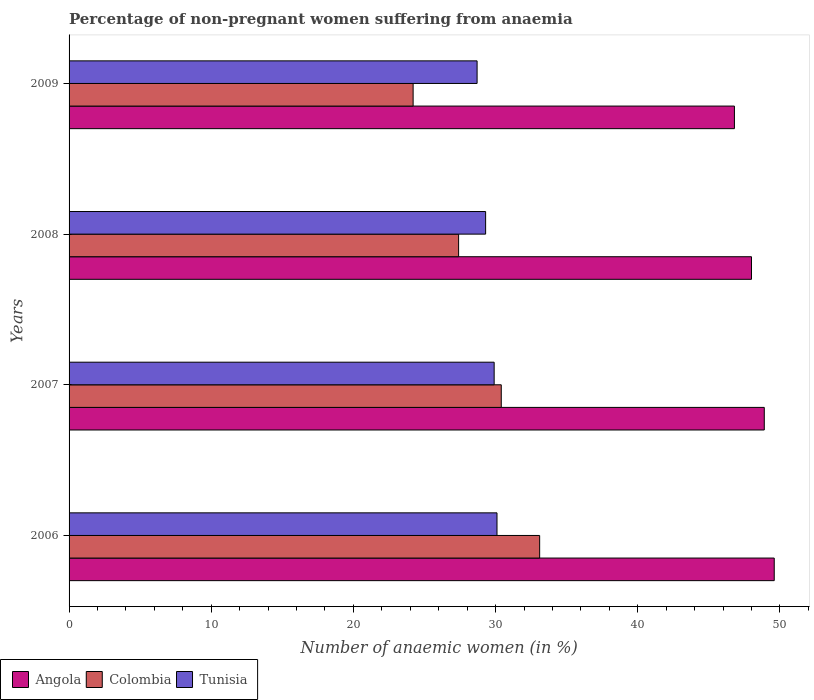How many bars are there on the 4th tick from the top?
Provide a succinct answer. 3. How many bars are there on the 2nd tick from the bottom?
Keep it short and to the point. 3. What is the label of the 3rd group of bars from the top?
Make the answer very short. 2007. What is the percentage of non-pregnant women suffering from anaemia in Angola in 2006?
Keep it short and to the point. 49.6. Across all years, what is the maximum percentage of non-pregnant women suffering from anaemia in Colombia?
Your answer should be very brief. 33.1. Across all years, what is the minimum percentage of non-pregnant women suffering from anaemia in Tunisia?
Make the answer very short. 28.7. In which year was the percentage of non-pregnant women suffering from anaemia in Colombia minimum?
Give a very brief answer. 2009. What is the total percentage of non-pregnant women suffering from anaemia in Angola in the graph?
Your response must be concise. 193.3. What is the difference between the percentage of non-pregnant women suffering from anaemia in Colombia in 2008 and that in 2009?
Your answer should be compact. 3.2. What is the difference between the percentage of non-pregnant women suffering from anaemia in Colombia in 2006 and the percentage of non-pregnant women suffering from anaemia in Tunisia in 2008?
Ensure brevity in your answer.  3.8. What is the average percentage of non-pregnant women suffering from anaemia in Colombia per year?
Make the answer very short. 28.78. In the year 2007, what is the difference between the percentage of non-pregnant women suffering from anaemia in Colombia and percentage of non-pregnant women suffering from anaemia in Tunisia?
Your answer should be very brief. 0.5. What is the ratio of the percentage of non-pregnant women suffering from anaemia in Tunisia in 2006 to that in 2008?
Keep it short and to the point. 1.03. Is the difference between the percentage of non-pregnant women suffering from anaemia in Colombia in 2006 and 2007 greater than the difference between the percentage of non-pregnant women suffering from anaemia in Tunisia in 2006 and 2007?
Offer a very short reply. Yes. What is the difference between the highest and the second highest percentage of non-pregnant women suffering from anaemia in Colombia?
Your response must be concise. 2.7. What is the difference between the highest and the lowest percentage of non-pregnant women suffering from anaemia in Colombia?
Offer a terse response. 8.9. In how many years, is the percentage of non-pregnant women suffering from anaemia in Colombia greater than the average percentage of non-pregnant women suffering from anaemia in Colombia taken over all years?
Your response must be concise. 2. What does the 1st bar from the top in 2007 represents?
Your answer should be very brief. Tunisia. What does the 3rd bar from the bottom in 2007 represents?
Keep it short and to the point. Tunisia. Is it the case that in every year, the sum of the percentage of non-pregnant women suffering from anaemia in Colombia and percentage of non-pregnant women suffering from anaemia in Tunisia is greater than the percentage of non-pregnant women suffering from anaemia in Angola?
Your response must be concise. Yes. Does the graph contain grids?
Make the answer very short. No. How many legend labels are there?
Offer a terse response. 3. What is the title of the graph?
Provide a succinct answer. Percentage of non-pregnant women suffering from anaemia. Does "Europe(all income levels)" appear as one of the legend labels in the graph?
Provide a short and direct response. No. What is the label or title of the X-axis?
Your answer should be compact. Number of anaemic women (in %). What is the label or title of the Y-axis?
Your response must be concise. Years. What is the Number of anaemic women (in %) of Angola in 2006?
Your answer should be very brief. 49.6. What is the Number of anaemic women (in %) of Colombia in 2006?
Provide a short and direct response. 33.1. What is the Number of anaemic women (in %) of Tunisia in 2006?
Offer a terse response. 30.1. What is the Number of anaemic women (in %) in Angola in 2007?
Your answer should be compact. 48.9. What is the Number of anaemic women (in %) of Colombia in 2007?
Your answer should be compact. 30.4. What is the Number of anaemic women (in %) in Tunisia in 2007?
Keep it short and to the point. 29.9. What is the Number of anaemic women (in %) of Colombia in 2008?
Give a very brief answer. 27.4. What is the Number of anaemic women (in %) in Tunisia in 2008?
Keep it short and to the point. 29.3. What is the Number of anaemic women (in %) of Angola in 2009?
Offer a very short reply. 46.8. What is the Number of anaemic women (in %) in Colombia in 2009?
Your response must be concise. 24.2. What is the Number of anaemic women (in %) of Tunisia in 2009?
Make the answer very short. 28.7. Across all years, what is the maximum Number of anaemic women (in %) in Angola?
Make the answer very short. 49.6. Across all years, what is the maximum Number of anaemic women (in %) of Colombia?
Your answer should be very brief. 33.1. Across all years, what is the maximum Number of anaemic women (in %) of Tunisia?
Your answer should be compact. 30.1. Across all years, what is the minimum Number of anaemic women (in %) in Angola?
Offer a very short reply. 46.8. Across all years, what is the minimum Number of anaemic women (in %) of Colombia?
Offer a very short reply. 24.2. Across all years, what is the minimum Number of anaemic women (in %) of Tunisia?
Provide a short and direct response. 28.7. What is the total Number of anaemic women (in %) in Angola in the graph?
Give a very brief answer. 193.3. What is the total Number of anaemic women (in %) of Colombia in the graph?
Your answer should be compact. 115.1. What is the total Number of anaemic women (in %) of Tunisia in the graph?
Provide a short and direct response. 118. What is the difference between the Number of anaemic women (in %) of Tunisia in 2006 and that in 2007?
Your answer should be compact. 0.2. What is the difference between the Number of anaemic women (in %) of Tunisia in 2006 and that in 2008?
Keep it short and to the point. 0.8. What is the difference between the Number of anaemic women (in %) in Colombia in 2006 and that in 2009?
Keep it short and to the point. 8.9. What is the difference between the Number of anaemic women (in %) in Angola in 2007 and that in 2008?
Your answer should be compact. 0.9. What is the difference between the Number of anaemic women (in %) in Angola in 2007 and that in 2009?
Ensure brevity in your answer.  2.1. What is the difference between the Number of anaemic women (in %) of Tunisia in 2007 and that in 2009?
Your answer should be very brief. 1.2. What is the difference between the Number of anaemic women (in %) of Angola in 2008 and that in 2009?
Give a very brief answer. 1.2. What is the difference between the Number of anaemic women (in %) in Colombia in 2008 and that in 2009?
Your response must be concise. 3.2. What is the difference between the Number of anaemic women (in %) in Tunisia in 2008 and that in 2009?
Make the answer very short. 0.6. What is the difference between the Number of anaemic women (in %) in Angola in 2006 and the Number of anaemic women (in %) in Colombia in 2007?
Make the answer very short. 19.2. What is the difference between the Number of anaemic women (in %) of Angola in 2006 and the Number of anaemic women (in %) of Tunisia in 2007?
Keep it short and to the point. 19.7. What is the difference between the Number of anaemic women (in %) in Colombia in 2006 and the Number of anaemic women (in %) in Tunisia in 2007?
Your answer should be compact. 3.2. What is the difference between the Number of anaemic women (in %) of Angola in 2006 and the Number of anaemic women (in %) of Colombia in 2008?
Offer a very short reply. 22.2. What is the difference between the Number of anaemic women (in %) in Angola in 2006 and the Number of anaemic women (in %) in Tunisia in 2008?
Provide a short and direct response. 20.3. What is the difference between the Number of anaemic women (in %) of Angola in 2006 and the Number of anaemic women (in %) of Colombia in 2009?
Provide a short and direct response. 25.4. What is the difference between the Number of anaemic women (in %) in Angola in 2006 and the Number of anaemic women (in %) in Tunisia in 2009?
Make the answer very short. 20.9. What is the difference between the Number of anaemic women (in %) of Angola in 2007 and the Number of anaemic women (in %) of Tunisia in 2008?
Your response must be concise. 19.6. What is the difference between the Number of anaemic women (in %) of Colombia in 2007 and the Number of anaemic women (in %) of Tunisia in 2008?
Make the answer very short. 1.1. What is the difference between the Number of anaemic women (in %) of Angola in 2007 and the Number of anaemic women (in %) of Colombia in 2009?
Provide a short and direct response. 24.7. What is the difference between the Number of anaemic women (in %) of Angola in 2007 and the Number of anaemic women (in %) of Tunisia in 2009?
Provide a short and direct response. 20.2. What is the difference between the Number of anaemic women (in %) in Angola in 2008 and the Number of anaemic women (in %) in Colombia in 2009?
Make the answer very short. 23.8. What is the difference between the Number of anaemic women (in %) in Angola in 2008 and the Number of anaemic women (in %) in Tunisia in 2009?
Your answer should be compact. 19.3. What is the difference between the Number of anaemic women (in %) in Colombia in 2008 and the Number of anaemic women (in %) in Tunisia in 2009?
Give a very brief answer. -1.3. What is the average Number of anaemic women (in %) in Angola per year?
Provide a short and direct response. 48.33. What is the average Number of anaemic women (in %) of Colombia per year?
Give a very brief answer. 28.77. What is the average Number of anaemic women (in %) in Tunisia per year?
Your response must be concise. 29.5. In the year 2006, what is the difference between the Number of anaemic women (in %) in Colombia and Number of anaemic women (in %) in Tunisia?
Your answer should be very brief. 3. In the year 2007, what is the difference between the Number of anaemic women (in %) of Angola and Number of anaemic women (in %) of Colombia?
Offer a very short reply. 18.5. In the year 2007, what is the difference between the Number of anaemic women (in %) in Colombia and Number of anaemic women (in %) in Tunisia?
Provide a short and direct response. 0.5. In the year 2008, what is the difference between the Number of anaemic women (in %) of Angola and Number of anaemic women (in %) of Colombia?
Keep it short and to the point. 20.6. In the year 2008, what is the difference between the Number of anaemic women (in %) in Angola and Number of anaemic women (in %) in Tunisia?
Keep it short and to the point. 18.7. In the year 2008, what is the difference between the Number of anaemic women (in %) of Colombia and Number of anaemic women (in %) of Tunisia?
Your answer should be compact. -1.9. In the year 2009, what is the difference between the Number of anaemic women (in %) of Angola and Number of anaemic women (in %) of Colombia?
Your response must be concise. 22.6. In the year 2009, what is the difference between the Number of anaemic women (in %) in Angola and Number of anaemic women (in %) in Tunisia?
Keep it short and to the point. 18.1. In the year 2009, what is the difference between the Number of anaemic women (in %) in Colombia and Number of anaemic women (in %) in Tunisia?
Offer a very short reply. -4.5. What is the ratio of the Number of anaemic women (in %) in Angola in 2006 to that in 2007?
Make the answer very short. 1.01. What is the ratio of the Number of anaemic women (in %) of Colombia in 2006 to that in 2007?
Ensure brevity in your answer.  1.09. What is the ratio of the Number of anaemic women (in %) in Tunisia in 2006 to that in 2007?
Provide a succinct answer. 1.01. What is the ratio of the Number of anaemic women (in %) in Colombia in 2006 to that in 2008?
Make the answer very short. 1.21. What is the ratio of the Number of anaemic women (in %) of Tunisia in 2006 to that in 2008?
Your response must be concise. 1.03. What is the ratio of the Number of anaemic women (in %) of Angola in 2006 to that in 2009?
Give a very brief answer. 1.06. What is the ratio of the Number of anaemic women (in %) in Colombia in 2006 to that in 2009?
Your answer should be very brief. 1.37. What is the ratio of the Number of anaemic women (in %) of Tunisia in 2006 to that in 2009?
Your answer should be compact. 1.05. What is the ratio of the Number of anaemic women (in %) in Angola in 2007 to that in 2008?
Your answer should be very brief. 1.02. What is the ratio of the Number of anaemic women (in %) in Colombia in 2007 to that in 2008?
Make the answer very short. 1.11. What is the ratio of the Number of anaemic women (in %) in Tunisia in 2007 to that in 2008?
Your answer should be compact. 1.02. What is the ratio of the Number of anaemic women (in %) in Angola in 2007 to that in 2009?
Make the answer very short. 1.04. What is the ratio of the Number of anaemic women (in %) of Colombia in 2007 to that in 2009?
Keep it short and to the point. 1.26. What is the ratio of the Number of anaemic women (in %) in Tunisia in 2007 to that in 2009?
Offer a terse response. 1.04. What is the ratio of the Number of anaemic women (in %) in Angola in 2008 to that in 2009?
Ensure brevity in your answer.  1.03. What is the ratio of the Number of anaemic women (in %) in Colombia in 2008 to that in 2009?
Offer a terse response. 1.13. What is the ratio of the Number of anaemic women (in %) in Tunisia in 2008 to that in 2009?
Offer a terse response. 1.02. What is the difference between the highest and the second highest Number of anaemic women (in %) in Colombia?
Your response must be concise. 2.7. What is the difference between the highest and the lowest Number of anaemic women (in %) in Angola?
Your answer should be very brief. 2.8. What is the difference between the highest and the lowest Number of anaemic women (in %) of Colombia?
Your response must be concise. 8.9. What is the difference between the highest and the lowest Number of anaemic women (in %) of Tunisia?
Give a very brief answer. 1.4. 